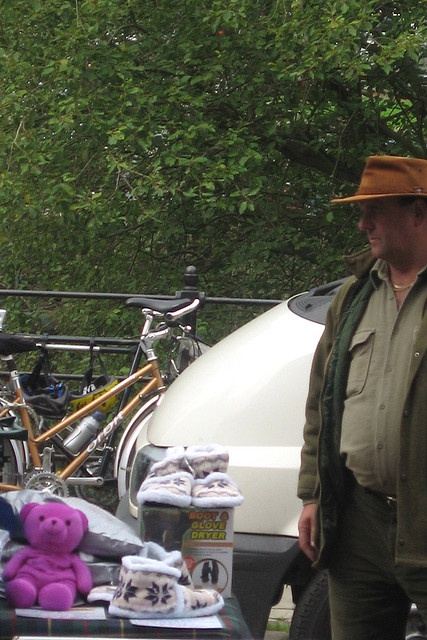Describe the objects in this image and their specific colors. I can see people in darkgreen, black, gray, and maroon tones, car in darkgreen, white, black, darkgray, and gray tones, bicycle in darkgreen, gray, black, darkgray, and lightgray tones, bicycle in darkgreen, black, gray, and darkgray tones, and teddy bear in darkgreen and purple tones in this image. 